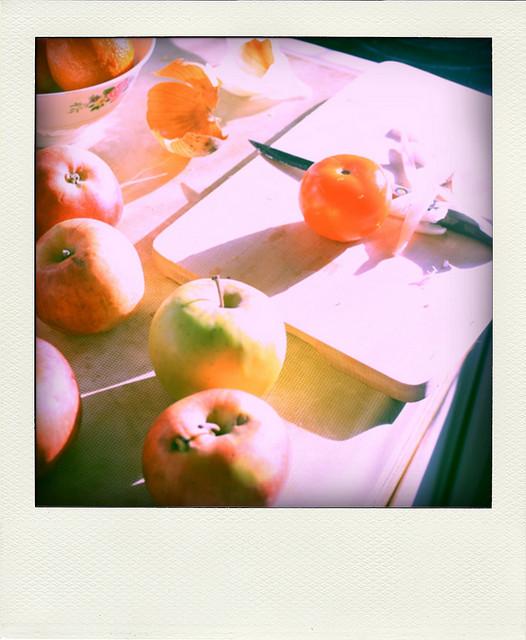Are there apples in the picture?
Quick response, please. Yes. Is there an item in this photo that could be used as a weapon?
Concise answer only. Yes. What different kind of apple are there?
Write a very short answer. Honeycrisp. 